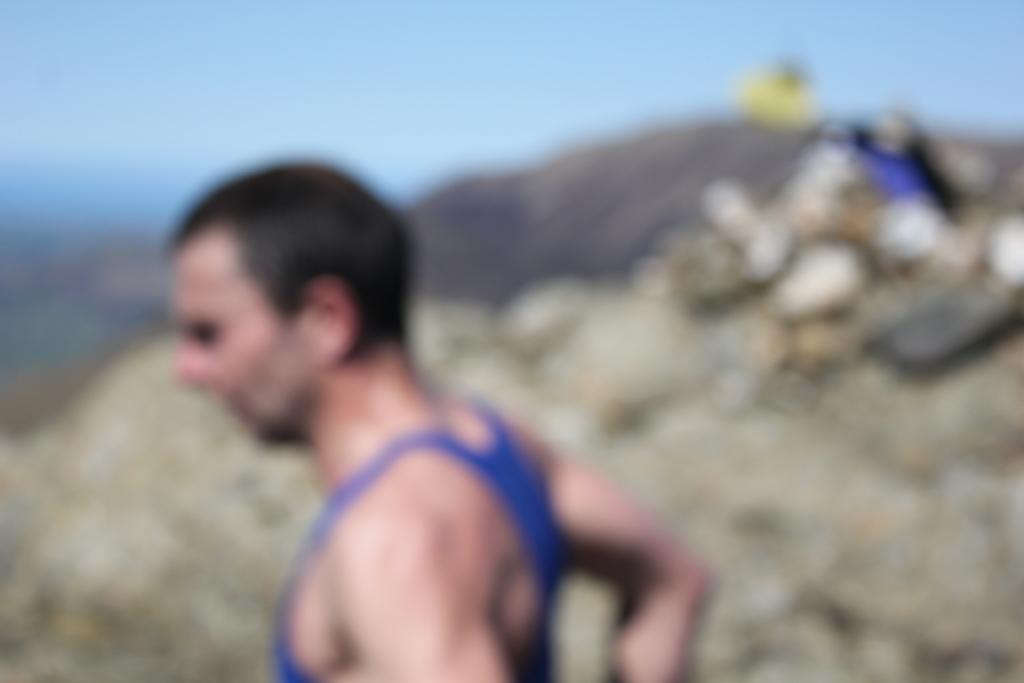What is the main subject in the image? There is a man standing in the image. What can be seen in the background of the image? The sky is visible in the image. Is there a hydrant next to the man in the image? There is no mention of a hydrant in the provided facts, so we cannot determine if one is present in the image. Does the man have a dog with him in the image? There is no mention of a dog in the provided facts, so we cannot determine if one is present in the image. 